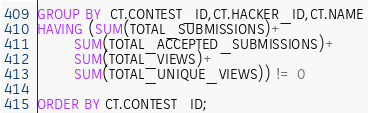Convert code to text. <code><loc_0><loc_0><loc_500><loc_500><_SQL_>
GROUP BY  CT.CONTEST_ID,CT.HACKER_ID,CT.NAME
HAVING (SUM(TOTAL_SUBMISSIONS)+
        SUM(TOTAL_ACCEPTED_SUBMISSIONS)+
        SUM(TOTAL_VIEWS)+
        SUM(TOTAL_UNIQUE_VIEWS)) != 0

ORDER BY CT.CONTEST_ID;


</code> 